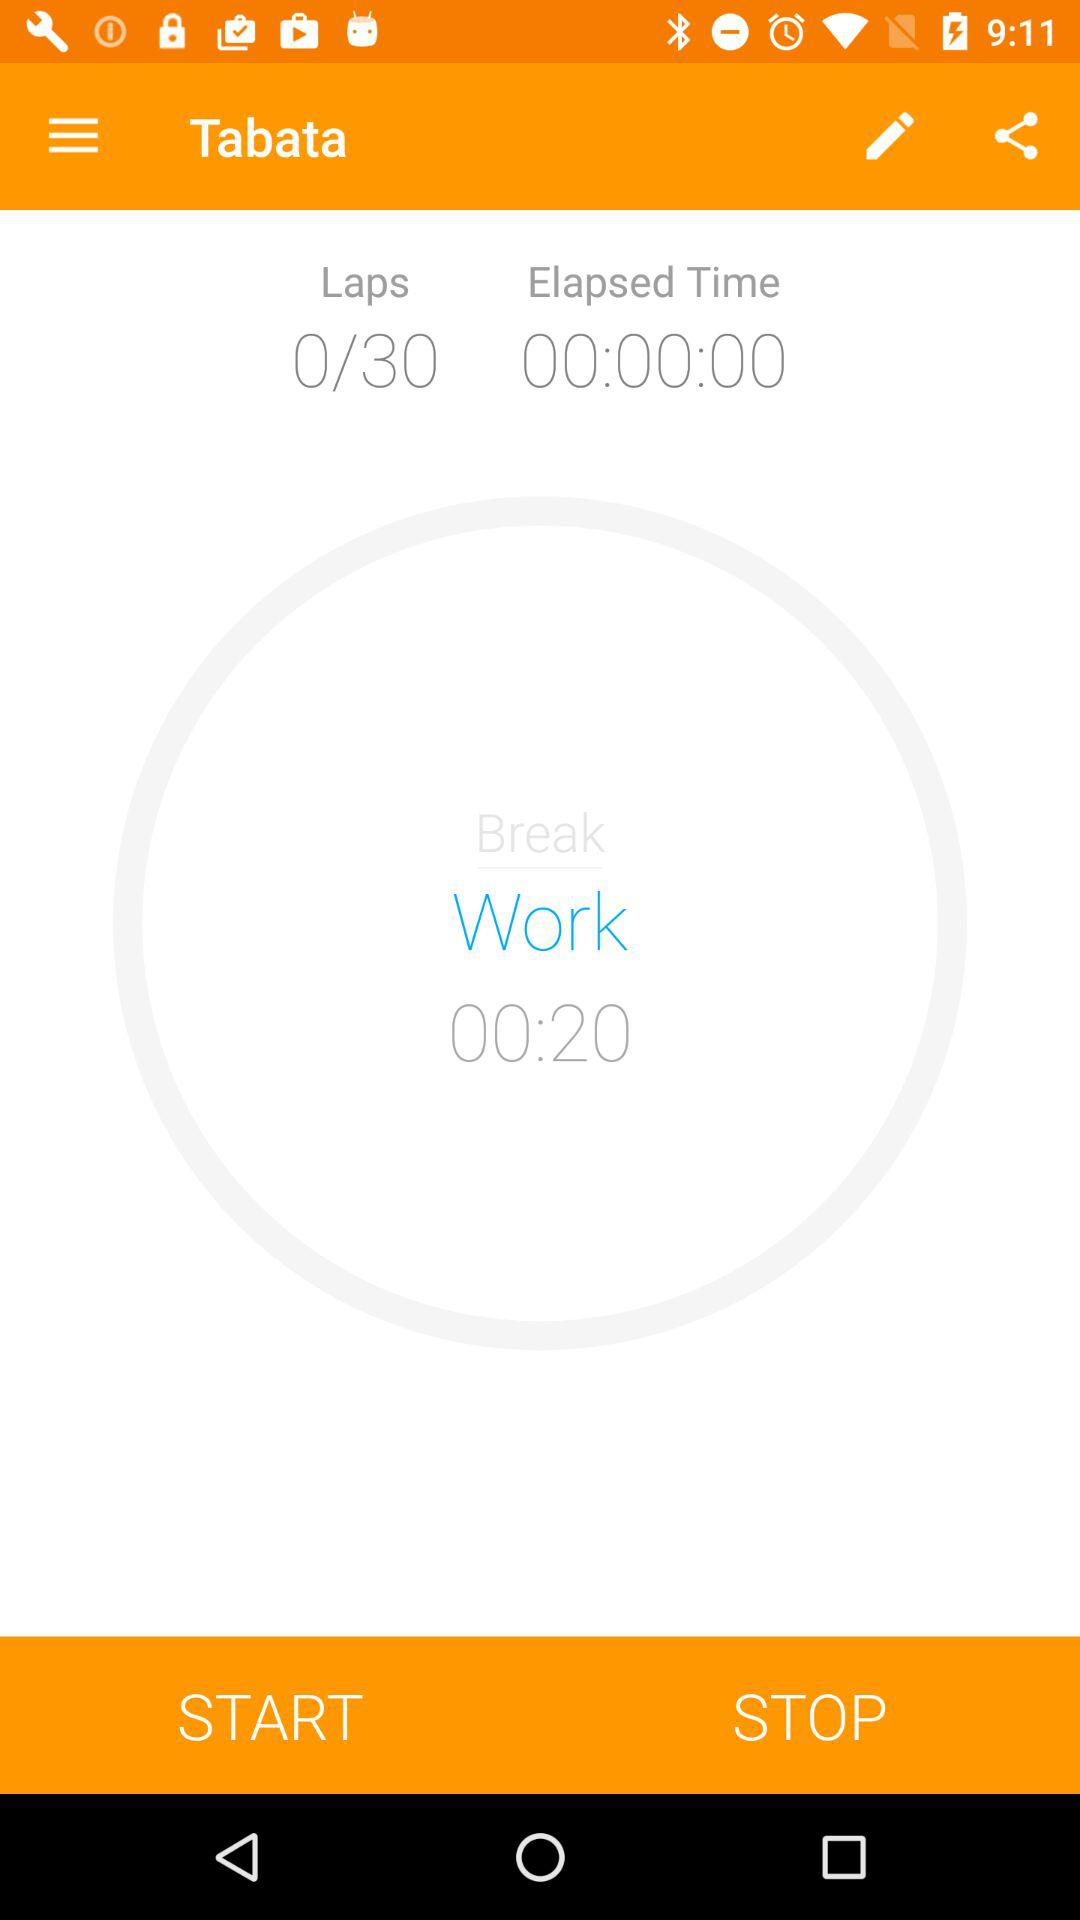How long has the work interval been going on for?
Answer the question using a single word or phrase. 00:20 